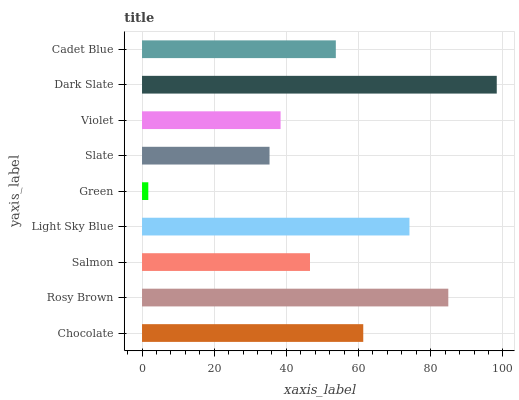Is Green the minimum?
Answer yes or no. Yes. Is Dark Slate the maximum?
Answer yes or no. Yes. Is Rosy Brown the minimum?
Answer yes or no. No. Is Rosy Brown the maximum?
Answer yes or no. No. Is Rosy Brown greater than Chocolate?
Answer yes or no. Yes. Is Chocolate less than Rosy Brown?
Answer yes or no. Yes. Is Chocolate greater than Rosy Brown?
Answer yes or no. No. Is Rosy Brown less than Chocolate?
Answer yes or no. No. Is Cadet Blue the high median?
Answer yes or no. Yes. Is Cadet Blue the low median?
Answer yes or no. Yes. Is Dark Slate the high median?
Answer yes or no. No. Is Chocolate the low median?
Answer yes or no. No. 